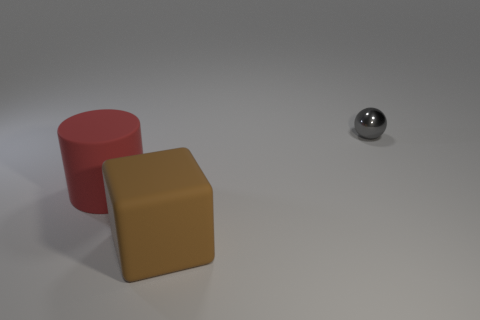Add 1 large brown rubber blocks. How many objects exist? 4 Subtract all balls. How many objects are left? 2 Subtract all tiny green rubber cylinders. Subtract all large matte blocks. How many objects are left? 2 Add 2 small metallic things. How many small metallic things are left? 3 Add 1 red cylinders. How many red cylinders exist? 2 Subtract 0 red cubes. How many objects are left? 3 